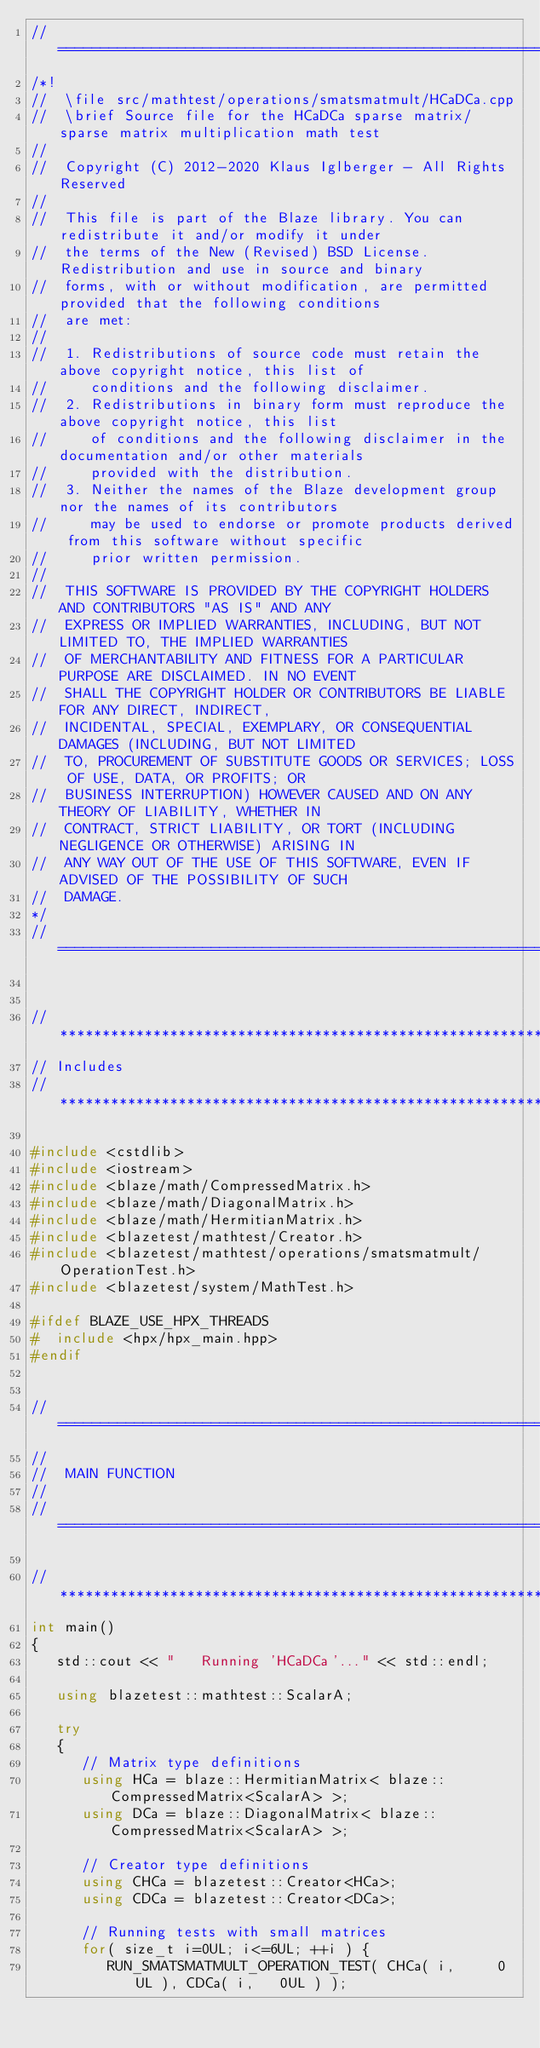<code> <loc_0><loc_0><loc_500><loc_500><_C++_>//=================================================================================================
/*!
//  \file src/mathtest/operations/smatsmatmult/HCaDCa.cpp
//  \brief Source file for the HCaDCa sparse matrix/sparse matrix multiplication math test
//
//  Copyright (C) 2012-2020 Klaus Iglberger - All Rights Reserved
//
//  This file is part of the Blaze library. You can redistribute it and/or modify it under
//  the terms of the New (Revised) BSD License. Redistribution and use in source and binary
//  forms, with or without modification, are permitted provided that the following conditions
//  are met:
//
//  1. Redistributions of source code must retain the above copyright notice, this list of
//     conditions and the following disclaimer.
//  2. Redistributions in binary form must reproduce the above copyright notice, this list
//     of conditions and the following disclaimer in the documentation and/or other materials
//     provided with the distribution.
//  3. Neither the names of the Blaze development group nor the names of its contributors
//     may be used to endorse or promote products derived from this software without specific
//     prior written permission.
//
//  THIS SOFTWARE IS PROVIDED BY THE COPYRIGHT HOLDERS AND CONTRIBUTORS "AS IS" AND ANY
//  EXPRESS OR IMPLIED WARRANTIES, INCLUDING, BUT NOT LIMITED TO, THE IMPLIED WARRANTIES
//  OF MERCHANTABILITY AND FITNESS FOR A PARTICULAR PURPOSE ARE DISCLAIMED. IN NO EVENT
//  SHALL THE COPYRIGHT HOLDER OR CONTRIBUTORS BE LIABLE FOR ANY DIRECT, INDIRECT,
//  INCIDENTAL, SPECIAL, EXEMPLARY, OR CONSEQUENTIAL DAMAGES (INCLUDING, BUT NOT LIMITED
//  TO, PROCUREMENT OF SUBSTITUTE GOODS OR SERVICES; LOSS OF USE, DATA, OR PROFITS; OR
//  BUSINESS INTERRUPTION) HOWEVER CAUSED AND ON ANY THEORY OF LIABILITY, WHETHER IN
//  CONTRACT, STRICT LIABILITY, OR TORT (INCLUDING NEGLIGENCE OR OTHERWISE) ARISING IN
//  ANY WAY OUT OF THE USE OF THIS SOFTWARE, EVEN IF ADVISED OF THE POSSIBILITY OF SUCH
//  DAMAGE.
*/
//=================================================================================================


//*************************************************************************************************
// Includes
//*************************************************************************************************

#include <cstdlib>
#include <iostream>
#include <blaze/math/CompressedMatrix.h>
#include <blaze/math/DiagonalMatrix.h>
#include <blaze/math/HermitianMatrix.h>
#include <blazetest/mathtest/Creator.h>
#include <blazetest/mathtest/operations/smatsmatmult/OperationTest.h>
#include <blazetest/system/MathTest.h>

#ifdef BLAZE_USE_HPX_THREADS
#  include <hpx/hpx_main.hpp>
#endif


//=================================================================================================
//
//  MAIN FUNCTION
//
//=================================================================================================

//*************************************************************************************************
int main()
{
   std::cout << "   Running 'HCaDCa'..." << std::endl;

   using blazetest::mathtest::ScalarA;

   try
   {
      // Matrix type definitions
      using HCa = blaze::HermitianMatrix< blaze::CompressedMatrix<ScalarA> >;
      using DCa = blaze::DiagonalMatrix< blaze::CompressedMatrix<ScalarA> >;

      // Creator type definitions
      using CHCa = blazetest::Creator<HCa>;
      using CDCa = blazetest::Creator<DCa>;

      // Running tests with small matrices
      for( size_t i=0UL; i<=6UL; ++i ) {
         RUN_SMATSMATMULT_OPERATION_TEST( CHCa( i,     0UL ), CDCa( i,   0UL ) );</code> 